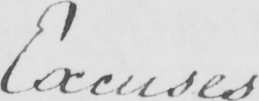Can you read and transcribe this handwriting? Excuses 